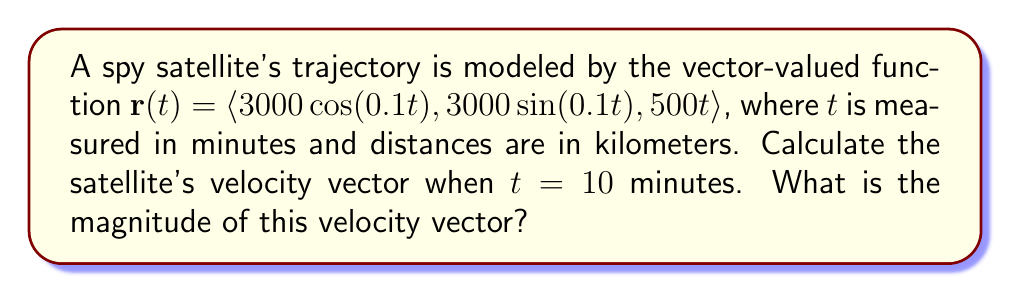Provide a solution to this math problem. To solve this problem, we'll follow these steps:

1) The velocity vector is the derivative of the position vector with respect to time. So, we need to find $\mathbf{r}'(t)$.

2) Let's differentiate each component of $\mathbf{r}(t)$:
   
   $\frac{d}{dt}(3000\cos(0.1t)) = -300\sin(0.1t)$
   $\frac{d}{dt}(3000\sin(0.1t)) = 300\cos(0.1t)$
   $\frac{d}{dt}(500t) = 500$

3) Therefore, the velocity vector is:
   
   $\mathbf{r}'(t) = \langle -300\sin(0.1t), 300\cos(0.1t), 500 \rangle$

4) Now, we need to evaluate this at $t = 10$:
   
   $\mathbf{r}'(10) = \langle -300\sin(1), 300\cos(1), 500 \rangle$

5) To find the magnitude of this vector, we use the formula:
   
   $\|\mathbf{v}\| = \sqrt{v_1^2 + v_2^2 + v_3^2}$

6) Substituting our values:
   
   $\|\mathbf{r}'(10)\| = \sqrt{(-300\sin(1))^2 + (300\cos(1))^2 + 500^2}$

7) Simplify:
   
   $\|\mathbf{r}'(10)\| = \sqrt{90000\sin^2(1) + 90000\cos^2(1) + 250000}$
   
   $= \sqrt{90000(\sin^2(1) + \cos^2(1)) + 250000}$
   
   $= \sqrt{90000 + 250000}$ (since $\sin^2(1) + \cos^2(1) = 1$)
   
   $= \sqrt{340000} \approx 583.10$ km/min
Answer: The velocity vector at $t = 10$ minutes is $\langle -300\sin(1), 300\cos(1), 500 \rangle$ km/min, and its magnitude is approximately 583.10 km/min. 